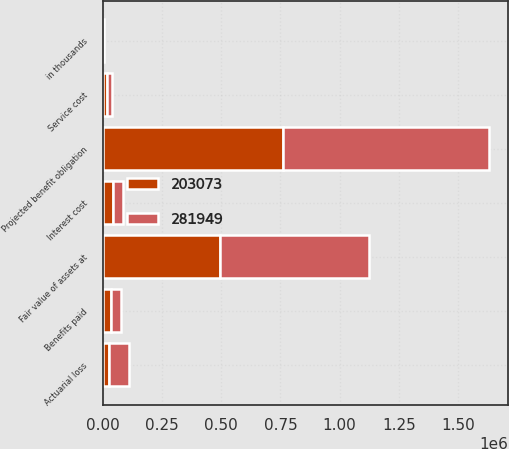Convert chart. <chart><loc_0><loc_0><loc_500><loc_500><stacked_bar_chart><ecel><fcel>in thousands<fcel>Projected benefit obligation<fcel>Service cost<fcel>Interest cost<fcel>Actuarial loss<fcel>Benefits paid<fcel>Fair value of assets at<nl><fcel>281949<fcel>2011<fcel>867374<fcel>20762<fcel>42383<fcel>81699<fcel>38854<fcel>630303<nl><fcel>203073<fcel>2010<fcel>761384<fcel>19217<fcel>41621<fcel>27094<fcel>36331<fcel>493646<nl></chart> 